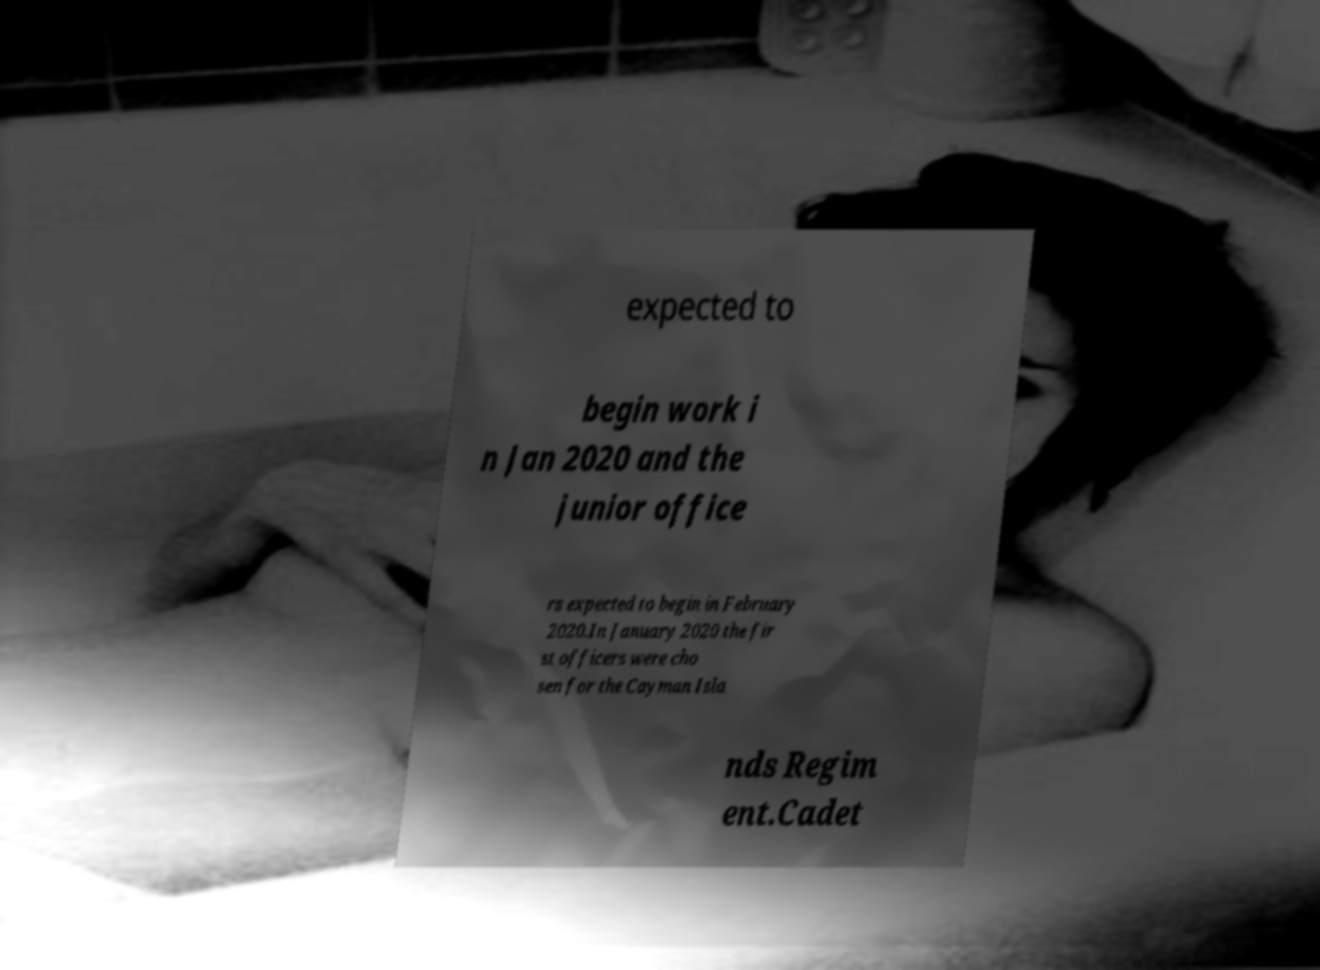Could you assist in decoding the text presented in this image and type it out clearly? expected to begin work i n Jan 2020 and the junior office rs expected to begin in February 2020.In January 2020 the fir st officers were cho sen for the Cayman Isla nds Regim ent.Cadet 